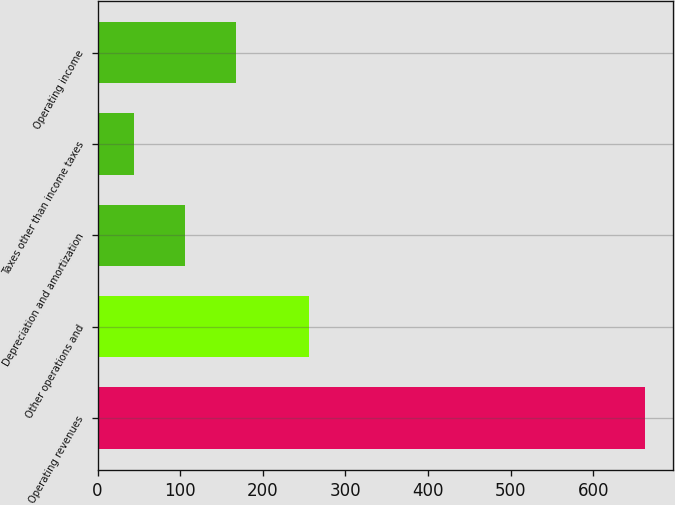Convert chart. <chart><loc_0><loc_0><loc_500><loc_500><bar_chart><fcel>Operating revenues<fcel>Other operations and<fcel>Depreciation and amortization<fcel>Taxes other than income taxes<fcel>Operating income<nl><fcel>663<fcel>256<fcel>105.9<fcel>44<fcel>167.8<nl></chart> 